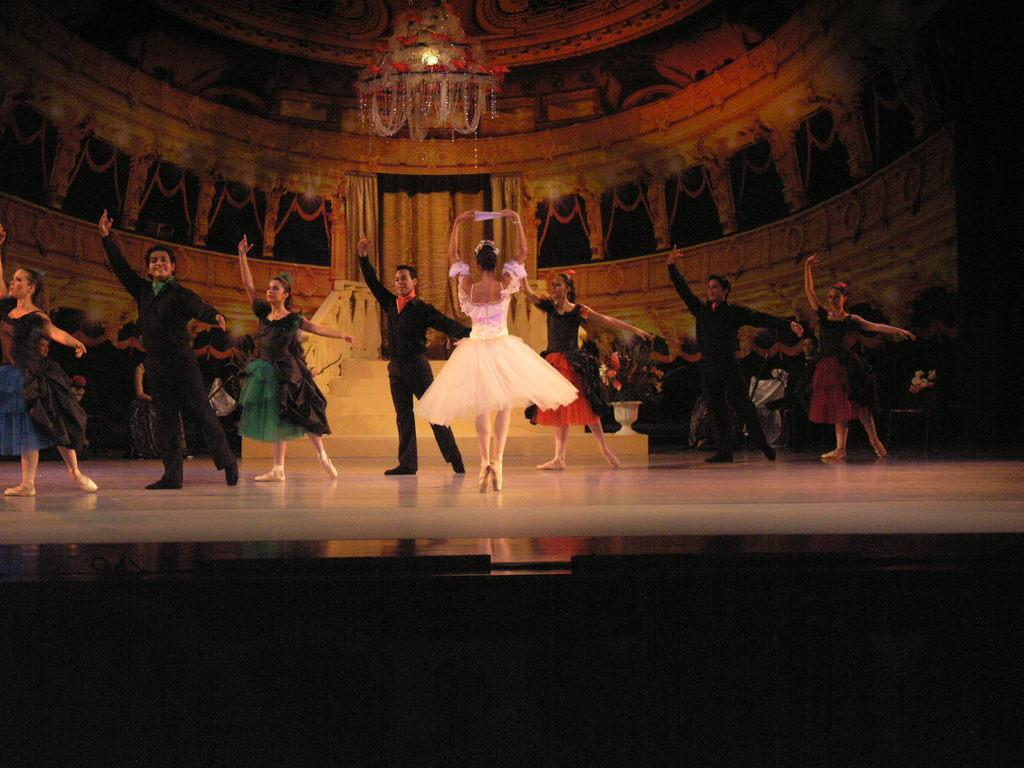What are the people in the image doing? The people in the image are dancing. What type of lighting fixture is present in the image? There is a chandelier in the image. Are there any architectural features visible in the image? Yes, there are stairs in the image. What type of background element can be seen in the image? There is a wall in the image. How many trucks are parked near the dancing people in the image? There are no trucks present in the image. What type of appliance is being used by the dancers in the image? There is no appliance being used by the dancers in the image. 